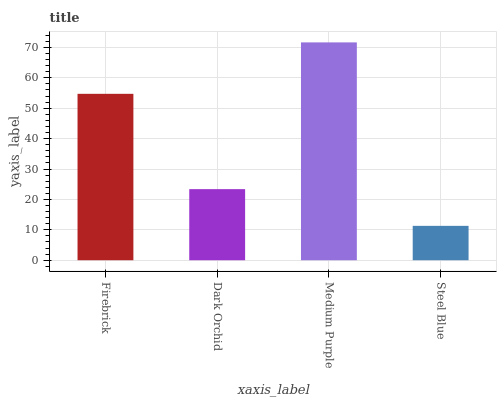Is Dark Orchid the minimum?
Answer yes or no. No. Is Dark Orchid the maximum?
Answer yes or no. No. Is Firebrick greater than Dark Orchid?
Answer yes or no. Yes. Is Dark Orchid less than Firebrick?
Answer yes or no. Yes. Is Dark Orchid greater than Firebrick?
Answer yes or no. No. Is Firebrick less than Dark Orchid?
Answer yes or no. No. Is Firebrick the high median?
Answer yes or no. Yes. Is Dark Orchid the low median?
Answer yes or no. Yes. Is Medium Purple the high median?
Answer yes or no. No. Is Medium Purple the low median?
Answer yes or no. No. 